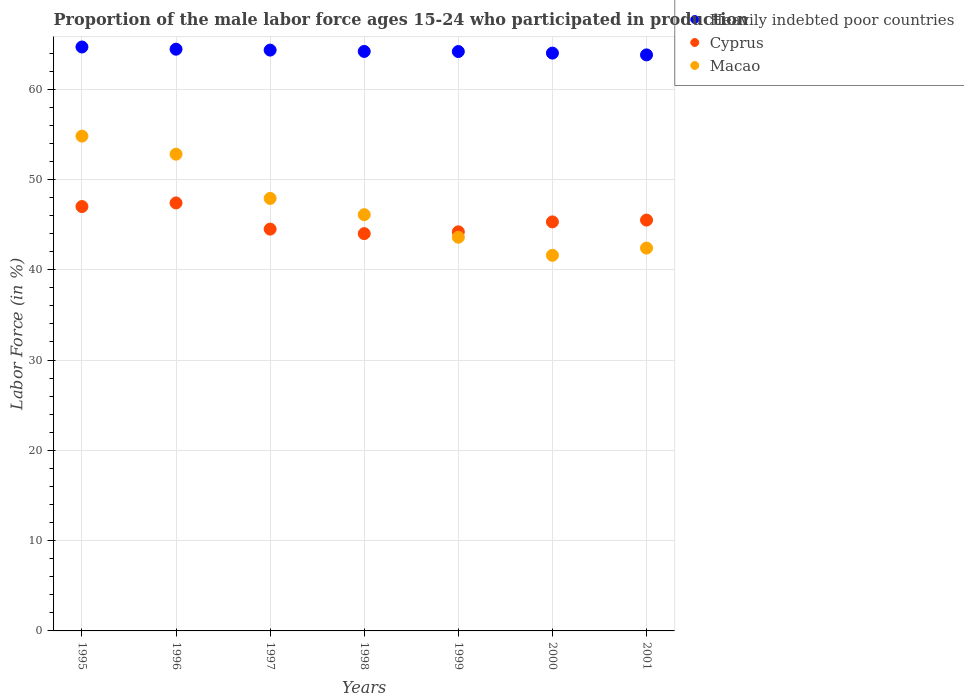What is the proportion of the male labor force who participated in production in Heavily indebted poor countries in 1998?
Provide a succinct answer. 64.18. Across all years, what is the maximum proportion of the male labor force who participated in production in Cyprus?
Keep it short and to the point. 47.4. Across all years, what is the minimum proportion of the male labor force who participated in production in Cyprus?
Ensure brevity in your answer.  44. In which year was the proportion of the male labor force who participated in production in Heavily indebted poor countries maximum?
Ensure brevity in your answer.  1995. In which year was the proportion of the male labor force who participated in production in Cyprus minimum?
Provide a short and direct response. 1998. What is the total proportion of the male labor force who participated in production in Cyprus in the graph?
Provide a succinct answer. 317.9. What is the difference between the proportion of the male labor force who participated in production in Cyprus in 1999 and the proportion of the male labor force who participated in production in Macao in 2001?
Your answer should be very brief. 1.8. What is the average proportion of the male labor force who participated in production in Heavily indebted poor countries per year?
Make the answer very short. 64.22. In the year 1998, what is the difference between the proportion of the male labor force who participated in production in Heavily indebted poor countries and proportion of the male labor force who participated in production in Macao?
Your answer should be very brief. 18.08. What is the ratio of the proportion of the male labor force who participated in production in Heavily indebted poor countries in 1995 to that in 2001?
Give a very brief answer. 1.01. Is the difference between the proportion of the male labor force who participated in production in Heavily indebted poor countries in 1999 and 2001 greater than the difference between the proportion of the male labor force who participated in production in Macao in 1999 and 2001?
Provide a short and direct response. No. What is the difference between the highest and the second highest proportion of the male labor force who participated in production in Cyprus?
Provide a succinct answer. 0.4. What is the difference between the highest and the lowest proportion of the male labor force who participated in production in Heavily indebted poor countries?
Provide a succinct answer. 0.87. Is the sum of the proportion of the male labor force who participated in production in Macao in 1995 and 1999 greater than the maximum proportion of the male labor force who participated in production in Heavily indebted poor countries across all years?
Your answer should be very brief. Yes. Does the proportion of the male labor force who participated in production in Cyprus monotonically increase over the years?
Keep it short and to the point. No. How many dotlines are there?
Offer a terse response. 3. How many years are there in the graph?
Give a very brief answer. 7. What is the difference between two consecutive major ticks on the Y-axis?
Your response must be concise. 10. Are the values on the major ticks of Y-axis written in scientific E-notation?
Provide a short and direct response. No. Does the graph contain grids?
Provide a short and direct response. Yes. How are the legend labels stacked?
Offer a very short reply. Vertical. What is the title of the graph?
Offer a very short reply. Proportion of the male labor force ages 15-24 who participated in production. Does "Turks and Caicos Islands" appear as one of the legend labels in the graph?
Ensure brevity in your answer.  No. What is the label or title of the X-axis?
Your response must be concise. Years. What is the label or title of the Y-axis?
Keep it short and to the point. Labor Force (in %). What is the Labor Force (in %) of Heavily indebted poor countries in 1995?
Give a very brief answer. 64.67. What is the Labor Force (in %) of Cyprus in 1995?
Give a very brief answer. 47. What is the Labor Force (in %) of Macao in 1995?
Ensure brevity in your answer.  54.8. What is the Labor Force (in %) of Heavily indebted poor countries in 1996?
Provide a short and direct response. 64.43. What is the Labor Force (in %) in Cyprus in 1996?
Offer a very short reply. 47.4. What is the Labor Force (in %) of Macao in 1996?
Your answer should be compact. 52.8. What is the Labor Force (in %) in Heavily indebted poor countries in 1997?
Ensure brevity in your answer.  64.33. What is the Labor Force (in %) in Cyprus in 1997?
Your response must be concise. 44.5. What is the Labor Force (in %) in Macao in 1997?
Make the answer very short. 47.9. What is the Labor Force (in %) in Heavily indebted poor countries in 1998?
Provide a short and direct response. 64.18. What is the Labor Force (in %) in Macao in 1998?
Your answer should be compact. 46.1. What is the Labor Force (in %) of Heavily indebted poor countries in 1999?
Offer a very short reply. 64.17. What is the Labor Force (in %) of Cyprus in 1999?
Make the answer very short. 44.2. What is the Labor Force (in %) in Macao in 1999?
Your answer should be compact. 43.6. What is the Labor Force (in %) of Heavily indebted poor countries in 2000?
Offer a very short reply. 63.99. What is the Labor Force (in %) of Cyprus in 2000?
Your answer should be compact. 45.3. What is the Labor Force (in %) of Macao in 2000?
Keep it short and to the point. 41.6. What is the Labor Force (in %) in Heavily indebted poor countries in 2001?
Your answer should be very brief. 63.8. What is the Labor Force (in %) in Cyprus in 2001?
Ensure brevity in your answer.  45.5. What is the Labor Force (in %) in Macao in 2001?
Ensure brevity in your answer.  42.4. Across all years, what is the maximum Labor Force (in %) in Heavily indebted poor countries?
Offer a terse response. 64.67. Across all years, what is the maximum Labor Force (in %) of Cyprus?
Provide a succinct answer. 47.4. Across all years, what is the maximum Labor Force (in %) of Macao?
Your response must be concise. 54.8. Across all years, what is the minimum Labor Force (in %) of Heavily indebted poor countries?
Offer a terse response. 63.8. Across all years, what is the minimum Labor Force (in %) in Macao?
Give a very brief answer. 41.6. What is the total Labor Force (in %) of Heavily indebted poor countries in the graph?
Make the answer very short. 449.56. What is the total Labor Force (in %) of Cyprus in the graph?
Ensure brevity in your answer.  317.9. What is the total Labor Force (in %) in Macao in the graph?
Your answer should be compact. 329.2. What is the difference between the Labor Force (in %) of Heavily indebted poor countries in 1995 and that in 1996?
Give a very brief answer. 0.24. What is the difference between the Labor Force (in %) in Cyprus in 1995 and that in 1996?
Offer a very short reply. -0.4. What is the difference between the Labor Force (in %) in Heavily indebted poor countries in 1995 and that in 1997?
Offer a very short reply. 0.35. What is the difference between the Labor Force (in %) of Macao in 1995 and that in 1997?
Ensure brevity in your answer.  6.9. What is the difference between the Labor Force (in %) of Heavily indebted poor countries in 1995 and that in 1998?
Provide a succinct answer. 0.49. What is the difference between the Labor Force (in %) of Cyprus in 1995 and that in 1998?
Make the answer very short. 3. What is the difference between the Labor Force (in %) in Heavily indebted poor countries in 1995 and that in 1999?
Your answer should be very brief. 0.5. What is the difference between the Labor Force (in %) of Cyprus in 1995 and that in 1999?
Make the answer very short. 2.8. What is the difference between the Labor Force (in %) in Macao in 1995 and that in 1999?
Ensure brevity in your answer.  11.2. What is the difference between the Labor Force (in %) in Heavily indebted poor countries in 1995 and that in 2000?
Offer a terse response. 0.68. What is the difference between the Labor Force (in %) of Cyprus in 1995 and that in 2000?
Your answer should be very brief. 1.7. What is the difference between the Labor Force (in %) in Heavily indebted poor countries in 1995 and that in 2001?
Make the answer very short. 0.87. What is the difference between the Labor Force (in %) in Cyprus in 1995 and that in 2001?
Keep it short and to the point. 1.5. What is the difference between the Labor Force (in %) of Heavily indebted poor countries in 1996 and that in 1997?
Offer a terse response. 0.1. What is the difference between the Labor Force (in %) of Cyprus in 1996 and that in 1997?
Your answer should be compact. 2.9. What is the difference between the Labor Force (in %) of Macao in 1996 and that in 1997?
Your answer should be compact. 4.9. What is the difference between the Labor Force (in %) in Heavily indebted poor countries in 1996 and that in 1998?
Keep it short and to the point. 0.25. What is the difference between the Labor Force (in %) in Cyprus in 1996 and that in 1998?
Offer a very short reply. 3.4. What is the difference between the Labor Force (in %) of Macao in 1996 and that in 1998?
Provide a short and direct response. 6.7. What is the difference between the Labor Force (in %) of Heavily indebted poor countries in 1996 and that in 1999?
Offer a terse response. 0.26. What is the difference between the Labor Force (in %) of Heavily indebted poor countries in 1996 and that in 2000?
Make the answer very short. 0.43. What is the difference between the Labor Force (in %) of Heavily indebted poor countries in 1996 and that in 2001?
Offer a terse response. 0.63. What is the difference between the Labor Force (in %) of Cyprus in 1996 and that in 2001?
Offer a very short reply. 1.9. What is the difference between the Labor Force (in %) of Heavily indebted poor countries in 1997 and that in 1998?
Provide a succinct answer. 0.15. What is the difference between the Labor Force (in %) of Heavily indebted poor countries in 1997 and that in 1999?
Give a very brief answer. 0.16. What is the difference between the Labor Force (in %) of Heavily indebted poor countries in 1997 and that in 2000?
Keep it short and to the point. 0.33. What is the difference between the Labor Force (in %) of Heavily indebted poor countries in 1997 and that in 2001?
Ensure brevity in your answer.  0.53. What is the difference between the Labor Force (in %) of Cyprus in 1997 and that in 2001?
Offer a very short reply. -1. What is the difference between the Labor Force (in %) in Macao in 1997 and that in 2001?
Provide a succinct answer. 5.5. What is the difference between the Labor Force (in %) in Heavily indebted poor countries in 1998 and that in 1999?
Ensure brevity in your answer.  0.01. What is the difference between the Labor Force (in %) of Cyprus in 1998 and that in 1999?
Provide a short and direct response. -0.2. What is the difference between the Labor Force (in %) of Macao in 1998 and that in 1999?
Offer a terse response. 2.5. What is the difference between the Labor Force (in %) in Heavily indebted poor countries in 1998 and that in 2000?
Make the answer very short. 0.18. What is the difference between the Labor Force (in %) in Heavily indebted poor countries in 1998 and that in 2001?
Provide a short and direct response. 0.38. What is the difference between the Labor Force (in %) of Heavily indebted poor countries in 1999 and that in 2000?
Your answer should be compact. 0.17. What is the difference between the Labor Force (in %) of Heavily indebted poor countries in 1999 and that in 2001?
Offer a very short reply. 0.37. What is the difference between the Labor Force (in %) of Cyprus in 1999 and that in 2001?
Offer a very short reply. -1.3. What is the difference between the Labor Force (in %) of Macao in 1999 and that in 2001?
Ensure brevity in your answer.  1.2. What is the difference between the Labor Force (in %) in Heavily indebted poor countries in 2000 and that in 2001?
Your answer should be very brief. 0.2. What is the difference between the Labor Force (in %) of Macao in 2000 and that in 2001?
Your answer should be compact. -0.8. What is the difference between the Labor Force (in %) of Heavily indebted poor countries in 1995 and the Labor Force (in %) of Cyprus in 1996?
Offer a terse response. 17.27. What is the difference between the Labor Force (in %) of Heavily indebted poor countries in 1995 and the Labor Force (in %) of Macao in 1996?
Your answer should be very brief. 11.87. What is the difference between the Labor Force (in %) in Heavily indebted poor countries in 1995 and the Labor Force (in %) in Cyprus in 1997?
Offer a very short reply. 20.17. What is the difference between the Labor Force (in %) in Heavily indebted poor countries in 1995 and the Labor Force (in %) in Macao in 1997?
Ensure brevity in your answer.  16.77. What is the difference between the Labor Force (in %) in Heavily indebted poor countries in 1995 and the Labor Force (in %) in Cyprus in 1998?
Offer a very short reply. 20.67. What is the difference between the Labor Force (in %) of Heavily indebted poor countries in 1995 and the Labor Force (in %) of Macao in 1998?
Your answer should be very brief. 18.57. What is the difference between the Labor Force (in %) of Heavily indebted poor countries in 1995 and the Labor Force (in %) of Cyprus in 1999?
Give a very brief answer. 20.47. What is the difference between the Labor Force (in %) in Heavily indebted poor countries in 1995 and the Labor Force (in %) in Macao in 1999?
Offer a very short reply. 21.07. What is the difference between the Labor Force (in %) of Heavily indebted poor countries in 1995 and the Labor Force (in %) of Cyprus in 2000?
Your answer should be compact. 19.37. What is the difference between the Labor Force (in %) of Heavily indebted poor countries in 1995 and the Labor Force (in %) of Macao in 2000?
Give a very brief answer. 23.07. What is the difference between the Labor Force (in %) of Heavily indebted poor countries in 1995 and the Labor Force (in %) of Cyprus in 2001?
Make the answer very short. 19.17. What is the difference between the Labor Force (in %) of Heavily indebted poor countries in 1995 and the Labor Force (in %) of Macao in 2001?
Offer a terse response. 22.27. What is the difference between the Labor Force (in %) in Heavily indebted poor countries in 1996 and the Labor Force (in %) in Cyprus in 1997?
Make the answer very short. 19.93. What is the difference between the Labor Force (in %) in Heavily indebted poor countries in 1996 and the Labor Force (in %) in Macao in 1997?
Offer a terse response. 16.53. What is the difference between the Labor Force (in %) in Heavily indebted poor countries in 1996 and the Labor Force (in %) in Cyprus in 1998?
Offer a terse response. 20.43. What is the difference between the Labor Force (in %) in Heavily indebted poor countries in 1996 and the Labor Force (in %) in Macao in 1998?
Your answer should be very brief. 18.33. What is the difference between the Labor Force (in %) of Cyprus in 1996 and the Labor Force (in %) of Macao in 1998?
Provide a short and direct response. 1.3. What is the difference between the Labor Force (in %) of Heavily indebted poor countries in 1996 and the Labor Force (in %) of Cyprus in 1999?
Provide a short and direct response. 20.23. What is the difference between the Labor Force (in %) of Heavily indebted poor countries in 1996 and the Labor Force (in %) of Macao in 1999?
Provide a succinct answer. 20.83. What is the difference between the Labor Force (in %) in Heavily indebted poor countries in 1996 and the Labor Force (in %) in Cyprus in 2000?
Make the answer very short. 19.13. What is the difference between the Labor Force (in %) of Heavily indebted poor countries in 1996 and the Labor Force (in %) of Macao in 2000?
Offer a terse response. 22.83. What is the difference between the Labor Force (in %) in Cyprus in 1996 and the Labor Force (in %) in Macao in 2000?
Your response must be concise. 5.8. What is the difference between the Labor Force (in %) of Heavily indebted poor countries in 1996 and the Labor Force (in %) of Cyprus in 2001?
Offer a very short reply. 18.93. What is the difference between the Labor Force (in %) in Heavily indebted poor countries in 1996 and the Labor Force (in %) in Macao in 2001?
Keep it short and to the point. 22.03. What is the difference between the Labor Force (in %) in Heavily indebted poor countries in 1997 and the Labor Force (in %) in Cyprus in 1998?
Your response must be concise. 20.33. What is the difference between the Labor Force (in %) in Heavily indebted poor countries in 1997 and the Labor Force (in %) in Macao in 1998?
Provide a succinct answer. 18.23. What is the difference between the Labor Force (in %) in Heavily indebted poor countries in 1997 and the Labor Force (in %) in Cyprus in 1999?
Give a very brief answer. 20.13. What is the difference between the Labor Force (in %) in Heavily indebted poor countries in 1997 and the Labor Force (in %) in Macao in 1999?
Your answer should be compact. 20.73. What is the difference between the Labor Force (in %) of Cyprus in 1997 and the Labor Force (in %) of Macao in 1999?
Give a very brief answer. 0.9. What is the difference between the Labor Force (in %) of Heavily indebted poor countries in 1997 and the Labor Force (in %) of Cyprus in 2000?
Offer a terse response. 19.03. What is the difference between the Labor Force (in %) of Heavily indebted poor countries in 1997 and the Labor Force (in %) of Macao in 2000?
Offer a terse response. 22.73. What is the difference between the Labor Force (in %) in Cyprus in 1997 and the Labor Force (in %) in Macao in 2000?
Make the answer very short. 2.9. What is the difference between the Labor Force (in %) in Heavily indebted poor countries in 1997 and the Labor Force (in %) in Cyprus in 2001?
Give a very brief answer. 18.83. What is the difference between the Labor Force (in %) of Heavily indebted poor countries in 1997 and the Labor Force (in %) of Macao in 2001?
Offer a very short reply. 21.93. What is the difference between the Labor Force (in %) in Cyprus in 1997 and the Labor Force (in %) in Macao in 2001?
Provide a short and direct response. 2.1. What is the difference between the Labor Force (in %) of Heavily indebted poor countries in 1998 and the Labor Force (in %) of Cyprus in 1999?
Provide a short and direct response. 19.98. What is the difference between the Labor Force (in %) of Heavily indebted poor countries in 1998 and the Labor Force (in %) of Macao in 1999?
Your answer should be compact. 20.58. What is the difference between the Labor Force (in %) in Cyprus in 1998 and the Labor Force (in %) in Macao in 1999?
Give a very brief answer. 0.4. What is the difference between the Labor Force (in %) in Heavily indebted poor countries in 1998 and the Labor Force (in %) in Cyprus in 2000?
Provide a succinct answer. 18.88. What is the difference between the Labor Force (in %) of Heavily indebted poor countries in 1998 and the Labor Force (in %) of Macao in 2000?
Offer a terse response. 22.58. What is the difference between the Labor Force (in %) of Cyprus in 1998 and the Labor Force (in %) of Macao in 2000?
Your answer should be compact. 2.4. What is the difference between the Labor Force (in %) in Heavily indebted poor countries in 1998 and the Labor Force (in %) in Cyprus in 2001?
Ensure brevity in your answer.  18.68. What is the difference between the Labor Force (in %) of Heavily indebted poor countries in 1998 and the Labor Force (in %) of Macao in 2001?
Provide a short and direct response. 21.78. What is the difference between the Labor Force (in %) of Cyprus in 1998 and the Labor Force (in %) of Macao in 2001?
Give a very brief answer. 1.6. What is the difference between the Labor Force (in %) of Heavily indebted poor countries in 1999 and the Labor Force (in %) of Cyprus in 2000?
Keep it short and to the point. 18.87. What is the difference between the Labor Force (in %) in Heavily indebted poor countries in 1999 and the Labor Force (in %) in Macao in 2000?
Make the answer very short. 22.57. What is the difference between the Labor Force (in %) of Cyprus in 1999 and the Labor Force (in %) of Macao in 2000?
Keep it short and to the point. 2.6. What is the difference between the Labor Force (in %) in Heavily indebted poor countries in 1999 and the Labor Force (in %) in Cyprus in 2001?
Your answer should be very brief. 18.67. What is the difference between the Labor Force (in %) in Heavily indebted poor countries in 1999 and the Labor Force (in %) in Macao in 2001?
Make the answer very short. 21.77. What is the difference between the Labor Force (in %) of Heavily indebted poor countries in 2000 and the Labor Force (in %) of Cyprus in 2001?
Ensure brevity in your answer.  18.49. What is the difference between the Labor Force (in %) in Heavily indebted poor countries in 2000 and the Labor Force (in %) in Macao in 2001?
Offer a terse response. 21.59. What is the average Labor Force (in %) in Heavily indebted poor countries per year?
Provide a succinct answer. 64.22. What is the average Labor Force (in %) in Cyprus per year?
Provide a short and direct response. 45.41. What is the average Labor Force (in %) in Macao per year?
Offer a terse response. 47.03. In the year 1995, what is the difference between the Labor Force (in %) in Heavily indebted poor countries and Labor Force (in %) in Cyprus?
Keep it short and to the point. 17.67. In the year 1995, what is the difference between the Labor Force (in %) of Heavily indebted poor countries and Labor Force (in %) of Macao?
Your answer should be very brief. 9.87. In the year 1995, what is the difference between the Labor Force (in %) in Cyprus and Labor Force (in %) in Macao?
Give a very brief answer. -7.8. In the year 1996, what is the difference between the Labor Force (in %) of Heavily indebted poor countries and Labor Force (in %) of Cyprus?
Provide a short and direct response. 17.03. In the year 1996, what is the difference between the Labor Force (in %) of Heavily indebted poor countries and Labor Force (in %) of Macao?
Your answer should be compact. 11.63. In the year 1996, what is the difference between the Labor Force (in %) of Cyprus and Labor Force (in %) of Macao?
Keep it short and to the point. -5.4. In the year 1997, what is the difference between the Labor Force (in %) of Heavily indebted poor countries and Labor Force (in %) of Cyprus?
Give a very brief answer. 19.83. In the year 1997, what is the difference between the Labor Force (in %) in Heavily indebted poor countries and Labor Force (in %) in Macao?
Make the answer very short. 16.43. In the year 1998, what is the difference between the Labor Force (in %) of Heavily indebted poor countries and Labor Force (in %) of Cyprus?
Provide a succinct answer. 20.18. In the year 1998, what is the difference between the Labor Force (in %) in Heavily indebted poor countries and Labor Force (in %) in Macao?
Ensure brevity in your answer.  18.08. In the year 1999, what is the difference between the Labor Force (in %) in Heavily indebted poor countries and Labor Force (in %) in Cyprus?
Give a very brief answer. 19.97. In the year 1999, what is the difference between the Labor Force (in %) of Heavily indebted poor countries and Labor Force (in %) of Macao?
Offer a very short reply. 20.57. In the year 1999, what is the difference between the Labor Force (in %) of Cyprus and Labor Force (in %) of Macao?
Provide a succinct answer. 0.6. In the year 2000, what is the difference between the Labor Force (in %) in Heavily indebted poor countries and Labor Force (in %) in Cyprus?
Keep it short and to the point. 18.69. In the year 2000, what is the difference between the Labor Force (in %) of Heavily indebted poor countries and Labor Force (in %) of Macao?
Give a very brief answer. 22.39. In the year 2001, what is the difference between the Labor Force (in %) of Heavily indebted poor countries and Labor Force (in %) of Cyprus?
Provide a short and direct response. 18.3. In the year 2001, what is the difference between the Labor Force (in %) of Heavily indebted poor countries and Labor Force (in %) of Macao?
Offer a very short reply. 21.4. What is the ratio of the Labor Force (in %) of Cyprus in 1995 to that in 1996?
Provide a succinct answer. 0.99. What is the ratio of the Labor Force (in %) of Macao in 1995 to that in 1996?
Provide a short and direct response. 1.04. What is the ratio of the Labor Force (in %) of Heavily indebted poor countries in 1995 to that in 1997?
Provide a succinct answer. 1.01. What is the ratio of the Labor Force (in %) of Cyprus in 1995 to that in 1997?
Offer a terse response. 1.06. What is the ratio of the Labor Force (in %) of Macao in 1995 to that in 1997?
Offer a very short reply. 1.14. What is the ratio of the Labor Force (in %) of Heavily indebted poor countries in 1995 to that in 1998?
Provide a short and direct response. 1.01. What is the ratio of the Labor Force (in %) of Cyprus in 1995 to that in 1998?
Provide a short and direct response. 1.07. What is the ratio of the Labor Force (in %) of Macao in 1995 to that in 1998?
Offer a terse response. 1.19. What is the ratio of the Labor Force (in %) of Cyprus in 1995 to that in 1999?
Ensure brevity in your answer.  1.06. What is the ratio of the Labor Force (in %) in Macao in 1995 to that in 1999?
Offer a very short reply. 1.26. What is the ratio of the Labor Force (in %) of Heavily indebted poor countries in 1995 to that in 2000?
Keep it short and to the point. 1.01. What is the ratio of the Labor Force (in %) of Cyprus in 1995 to that in 2000?
Give a very brief answer. 1.04. What is the ratio of the Labor Force (in %) in Macao in 1995 to that in 2000?
Make the answer very short. 1.32. What is the ratio of the Labor Force (in %) of Heavily indebted poor countries in 1995 to that in 2001?
Make the answer very short. 1.01. What is the ratio of the Labor Force (in %) in Cyprus in 1995 to that in 2001?
Give a very brief answer. 1.03. What is the ratio of the Labor Force (in %) in Macao in 1995 to that in 2001?
Your response must be concise. 1.29. What is the ratio of the Labor Force (in %) in Heavily indebted poor countries in 1996 to that in 1997?
Make the answer very short. 1. What is the ratio of the Labor Force (in %) in Cyprus in 1996 to that in 1997?
Your answer should be very brief. 1.07. What is the ratio of the Labor Force (in %) in Macao in 1996 to that in 1997?
Keep it short and to the point. 1.1. What is the ratio of the Labor Force (in %) in Cyprus in 1996 to that in 1998?
Your answer should be very brief. 1.08. What is the ratio of the Labor Force (in %) in Macao in 1996 to that in 1998?
Your answer should be very brief. 1.15. What is the ratio of the Labor Force (in %) in Cyprus in 1996 to that in 1999?
Ensure brevity in your answer.  1.07. What is the ratio of the Labor Force (in %) in Macao in 1996 to that in 1999?
Ensure brevity in your answer.  1.21. What is the ratio of the Labor Force (in %) in Heavily indebted poor countries in 1996 to that in 2000?
Give a very brief answer. 1.01. What is the ratio of the Labor Force (in %) in Cyprus in 1996 to that in 2000?
Ensure brevity in your answer.  1.05. What is the ratio of the Labor Force (in %) of Macao in 1996 to that in 2000?
Ensure brevity in your answer.  1.27. What is the ratio of the Labor Force (in %) of Heavily indebted poor countries in 1996 to that in 2001?
Your response must be concise. 1.01. What is the ratio of the Labor Force (in %) in Cyprus in 1996 to that in 2001?
Keep it short and to the point. 1.04. What is the ratio of the Labor Force (in %) in Macao in 1996 to that in 2001?
Your response must be concise. 1.25. What is the ratio of the Labor Force (in %) in Cyprus in 1997 to that in 1998?
Offer a terse response. 1.01. What is the ratio of the Labor Force (in %) in Macao in 1997 to that in 1998?
Make the answer very short. 1.04. What is the ratio of the Labor Force (in %) in Cyprus in 1997 to that in 1999?
Your response must be concise. 1.01. What is the ratio of the Labor Force (in %) of Macao in 1997 to that in 1999?
Provide a succinct answer. 1.1. What is the ratio of the Labor Force (in %) in Heavily indebted poor countries in 1997 to that in 2000?
Make the answer very short. 1.01. What is the ratio of the Labor Force (in %) of Cyprus in 1997 to that in 2000?
Offer a terse response. 0.98. What is the ratio of the Labor Force (in %) of Macao in 1997 to that in 2000?
Keep it short and to the point. 1.15. What is the ratio of the Labor Force (in %) of Heavily indebted poor countries in 1997 to that in 2001?
Provide a short and direct response. 1.01. What is the ratio of the Labor Force (in %) in Macao in 1997 to that in 2001?
Make the answer very short. 1.13. What is the ratio of the Labor Force (in %) in Heavily indebted poor countries in 1998 to that in 1999?
Offer a very short reply. 1. What is the ratio of the Labor Force (in %) of Macao in 1998 to that in 1999?
Your answer should be very brief. 1.06. What is the ratio of the Labor Force (in %) in Heavily indebted poor countries in 1998 to that in 2000?
Provide a short and direct response. 1. What is the ratio of the Labor Force (in %) of Cyprus in 1998 to that in 2000?
Ensure brevity in your answer.  0.97. What is the ratio of the Labor Force (in %) of Macao in 1998 to that in 2000?
Your response must be concise. 1.11. What is the ratio of the Labor Force (in %) of Macao in 1998 to that in 2001?
Give a very brief answer. 1.09. What is the ratio of the Labor Force (in %) in Cyprus in 1999 to that in 2000?
Give a very brief answer. 0.98. What is the ratio of the Labor Force (in %) of Macao in 1999 to that in 2000?
Keep it short and to the point. 1.05. What is the ratio of the Labor Force (in %) in Heavily indebted poor countries in 1999 to that in 2001?
Offer a terse response. 1.01. What is the ratio of the Labor Force (in %) in Cyprus in 1999 to that in 2001?
Offer a very short reply. 0.97. What is the ratio of the Labor Force (in %) in Macao in 1999 to that in 2001?
Keep it short and to the point. 1.03. What is the ratio of the Labor Force (in %) in Macao in 2000 to that in 2001?
Your answer should be compact. 0.98. What is the difference between the highest and the second highest Labor Force (in %) of Heavily indebted poor countries?
Make the answer very short. 0.24. What is the difference between the highest and the lowest Labor Force (in %) in Heavily indebted poor countries?
Provide a short and direct response. 0.87. What is the difference between the highest and the lowest Labor Force (in %) of Cyprus?
Provide a short and direct response. 3.4. What is the difference between the highest and the lowest Labor Force (in %) in Macao?
Offer a very short reply. 13.2. 